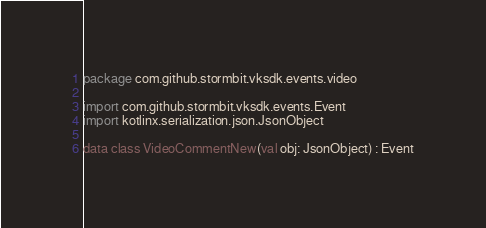<code> <loc_0><loc_0><loc_500><loc_500><_Kotlin_>package com.github.stormbit.vksdk.events.video

import com.github.stormbit.vksdk.events.Event
import kotlinx.serialization.json.JsonObject

data class VideoCommentNew(val obj: JsonObject) : Event</code> 